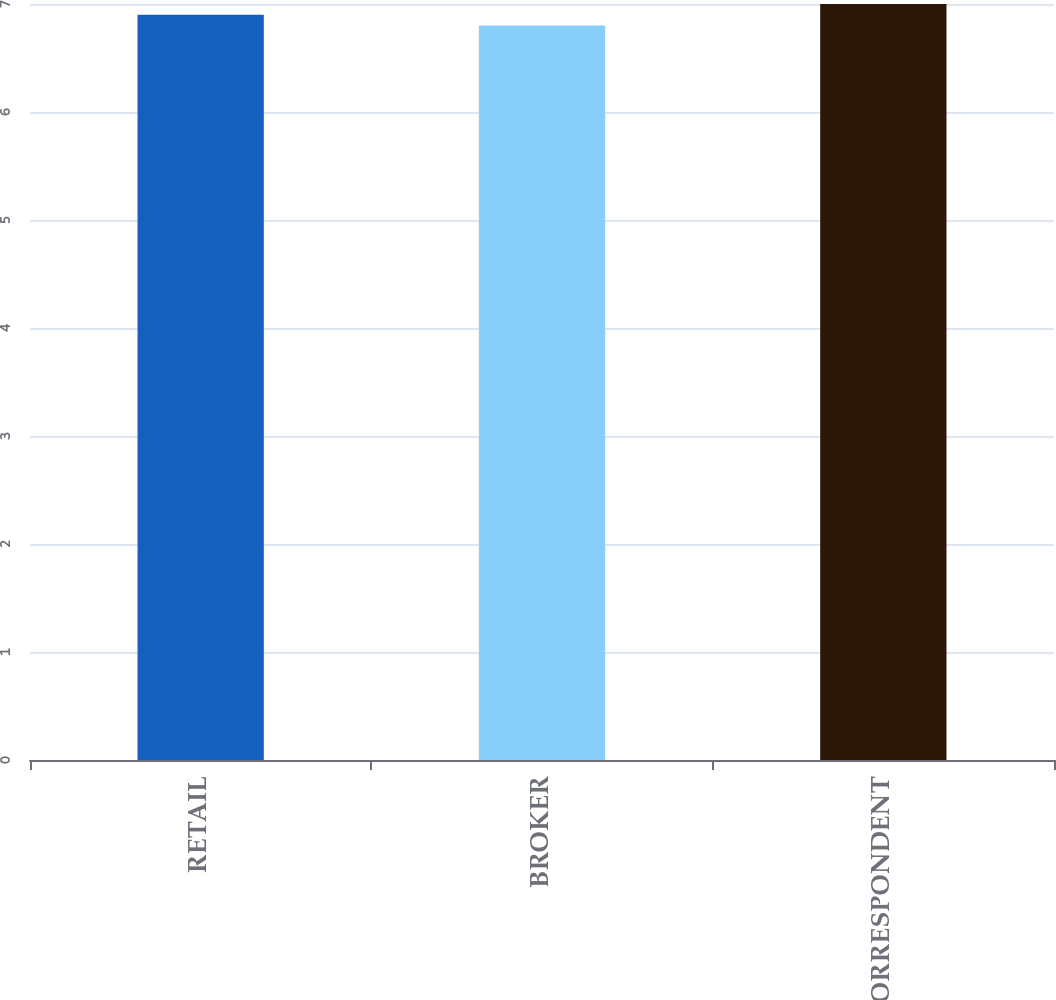<chart> <loc_0><loc_0><loc_500><loc_500><bar_chart><fcel>RETAIL<fcel>BROKER<fcel>CORRESPONDENT<nl><fcel>6.9<fcel>6.8<fcel>7<nl></chart> 